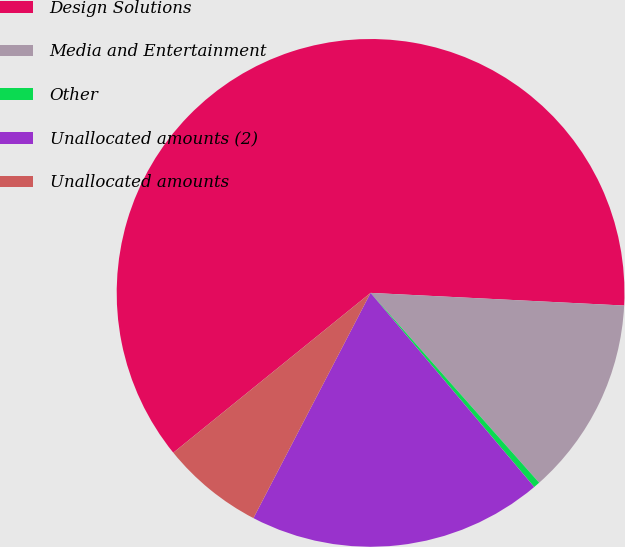<chart> <loc_0><loc_0><loc_500><loc_500><pie_chart><fcel>Design Solutions<fcel>Media and Entertainment<fcel>Other<fcel>Unallocated amounts (2)<fcel>Unallocated amounts<nl><fcel>61.63%<fcel>12.65%<fcel>0.41%<fcel>18.78%<fcel>6.53%<nl></chart> 